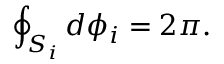<formula> <loc_0><loc_0><loc_500><loc_500>\oint _ { S _ { i } } { d \phi _ { i } } = 2 \pi .</formula> 